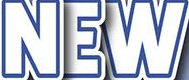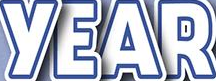Read the text content from these images in order, separated by a semicolon. NEW; YEAR 